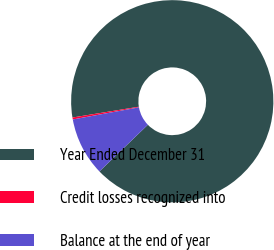<chart> <loc_0><loc_0><loc_500><loc_500><pie_chart><fcel>Year Ended December 31<fcel>Credit losses recognized into<fcel>Balance at the end of year<nl><fcel>90.37%<fcel>0.31%<fcel>9.32%<nl></chart> 